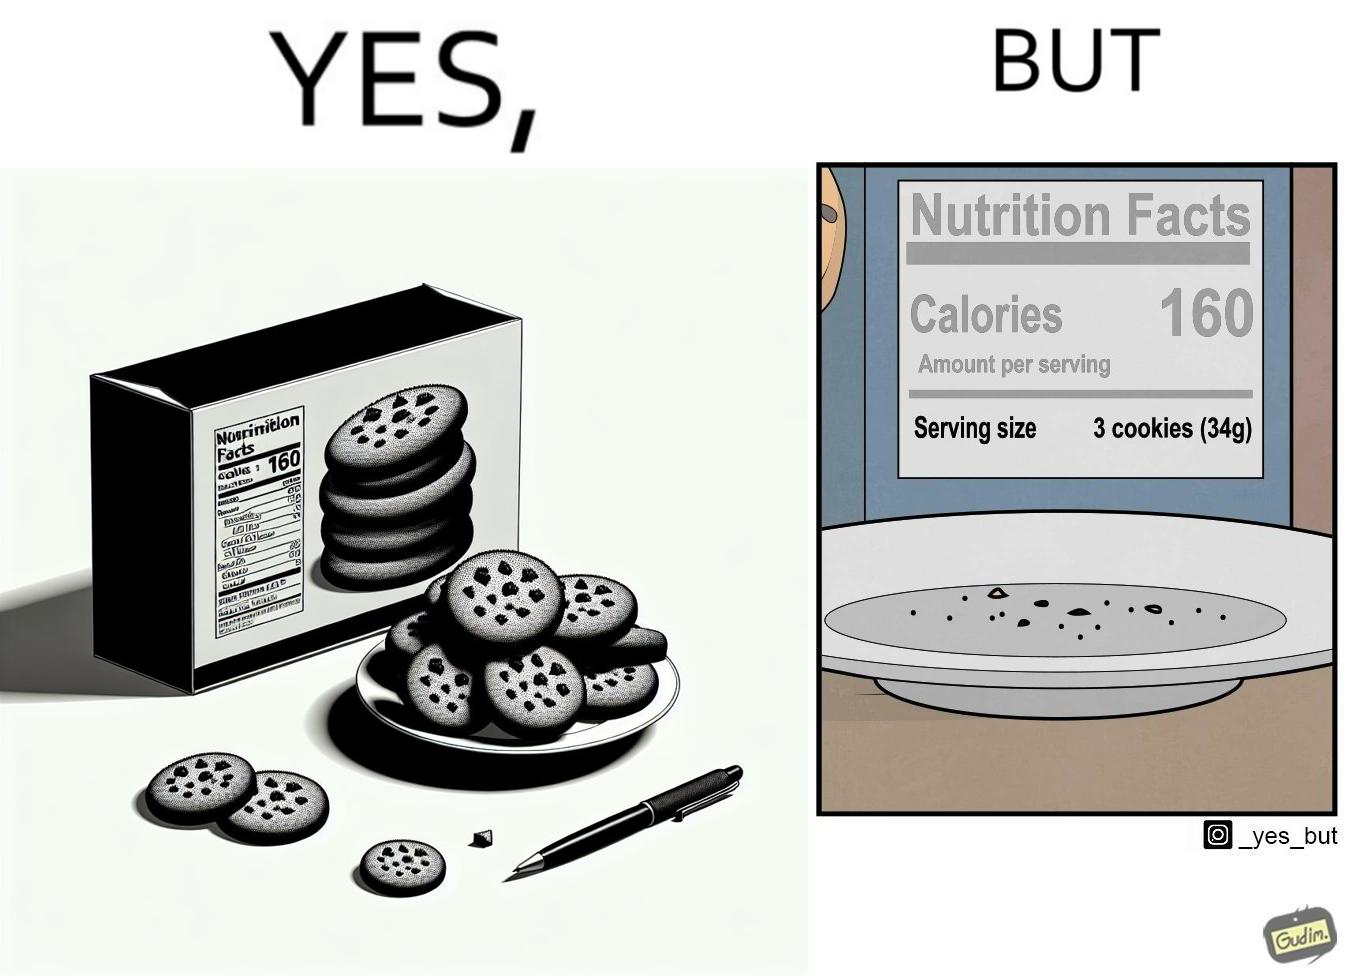Why is this image considered satirical? The image is funny because the full plate of cookies is hiding the entire nutrition facts leading readers to believe that the entire box of cookies amounts to just 160 calories but when all the cookies are eaten and the plate is empty, the rest of the nutrition table is visible which tells that each serving of cookies amounts to 160 calories where one serving consists of 3 cookies. 